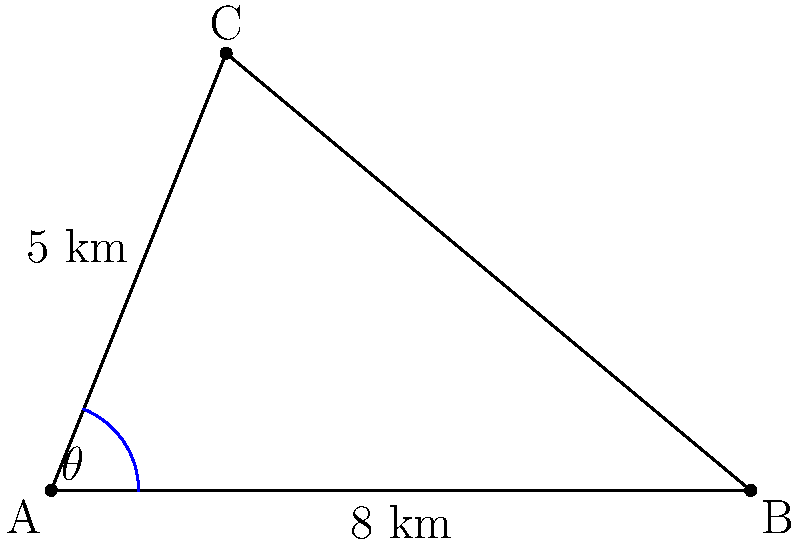During a memorable boating trip on Crystal Lake, you and your husband noticed two other boats. Your boat (C) was 5 km away from the shore at point A, while another boat (B) was 8 km along the shoreline from point A. If the angle $\theta$ between your boat and the other boat, as seen from point A, is 68°, what is the distance between your boat and the other boat? To solve this problem, we can use the law of cosines. Let's approach this step-by-step:

1) In the triangle ABC, we know:
   - Side AC = 5 km
   - Side AB = 8 km
   - Angle CAB = 68°

2) The law of cosines states:
   $BC^2 = AC^2 + AB^2 - 2(AC)(AB)\cos(\theta)$

3) Let's substitute our known values:
   $BC^2 = 5^2 + 8^2 - 2(5)(8)\cos(68°)$

4) Simplify:
   $BC^2 = 25 + 64 - 80\cos(68°)$

5) Calculate $\cos(68°)$:
   $\cos(68°) \approx 0.3746$

6) Substitute this value:
   $BC^2 = 25 + 64 - 80(0.3746)$
   $BC^2 = 89 - 29.968$
   $BC^2 = 59.032$

7) Take the square root of both sides:
   $BC = \sqrt{59.032} \approx 7.683$

Therefore, the distance between your boat and the other boat is approximately 7.68 km.
Answer: $7.68$ km 